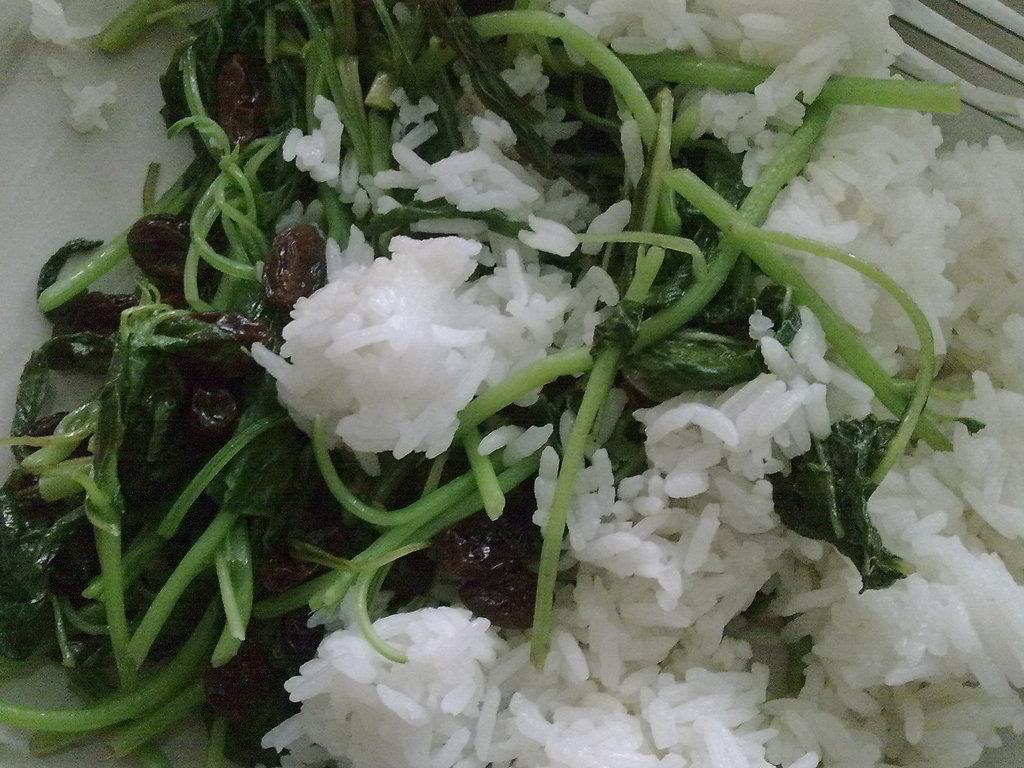What can be seen in the image? There is food visible in the image. Where is the food located? The food is on a surface. What type of clover can be seen growing near the food in the image? There is no clover present in the image. 